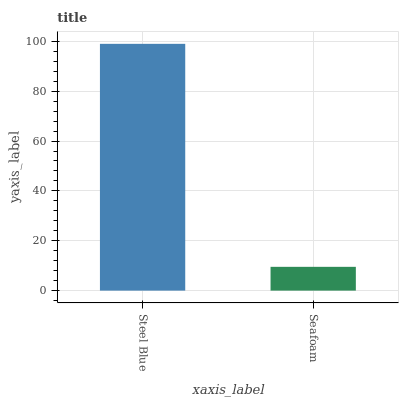Is Seafoam the minimum?
Answer yes or no. Yes. Is Steel Blue the maximum?
Answer yes or no. Yes. Is Seafoam the maximum?
Answer yes or no. No. Is Steel Blue greater than Seafoam?
Answer yes or no. Yes. Is Seafoam less than Steel Blue?
Answer yes or no. Yes. Is Seafoam greater than Steel Blue?
Answer yes or no. No. Is Steel Blue less than Seafoam?
Answer yes or no. No. Is Steel Blue the high median?
Answer yes or no. Yes. Is Seafoam the low median?
Answer yes or no. Yes. Is Seafoam the high median?
Answer yes or no. No. Is Steel Blue the low median?
Answer yes or no. No. 